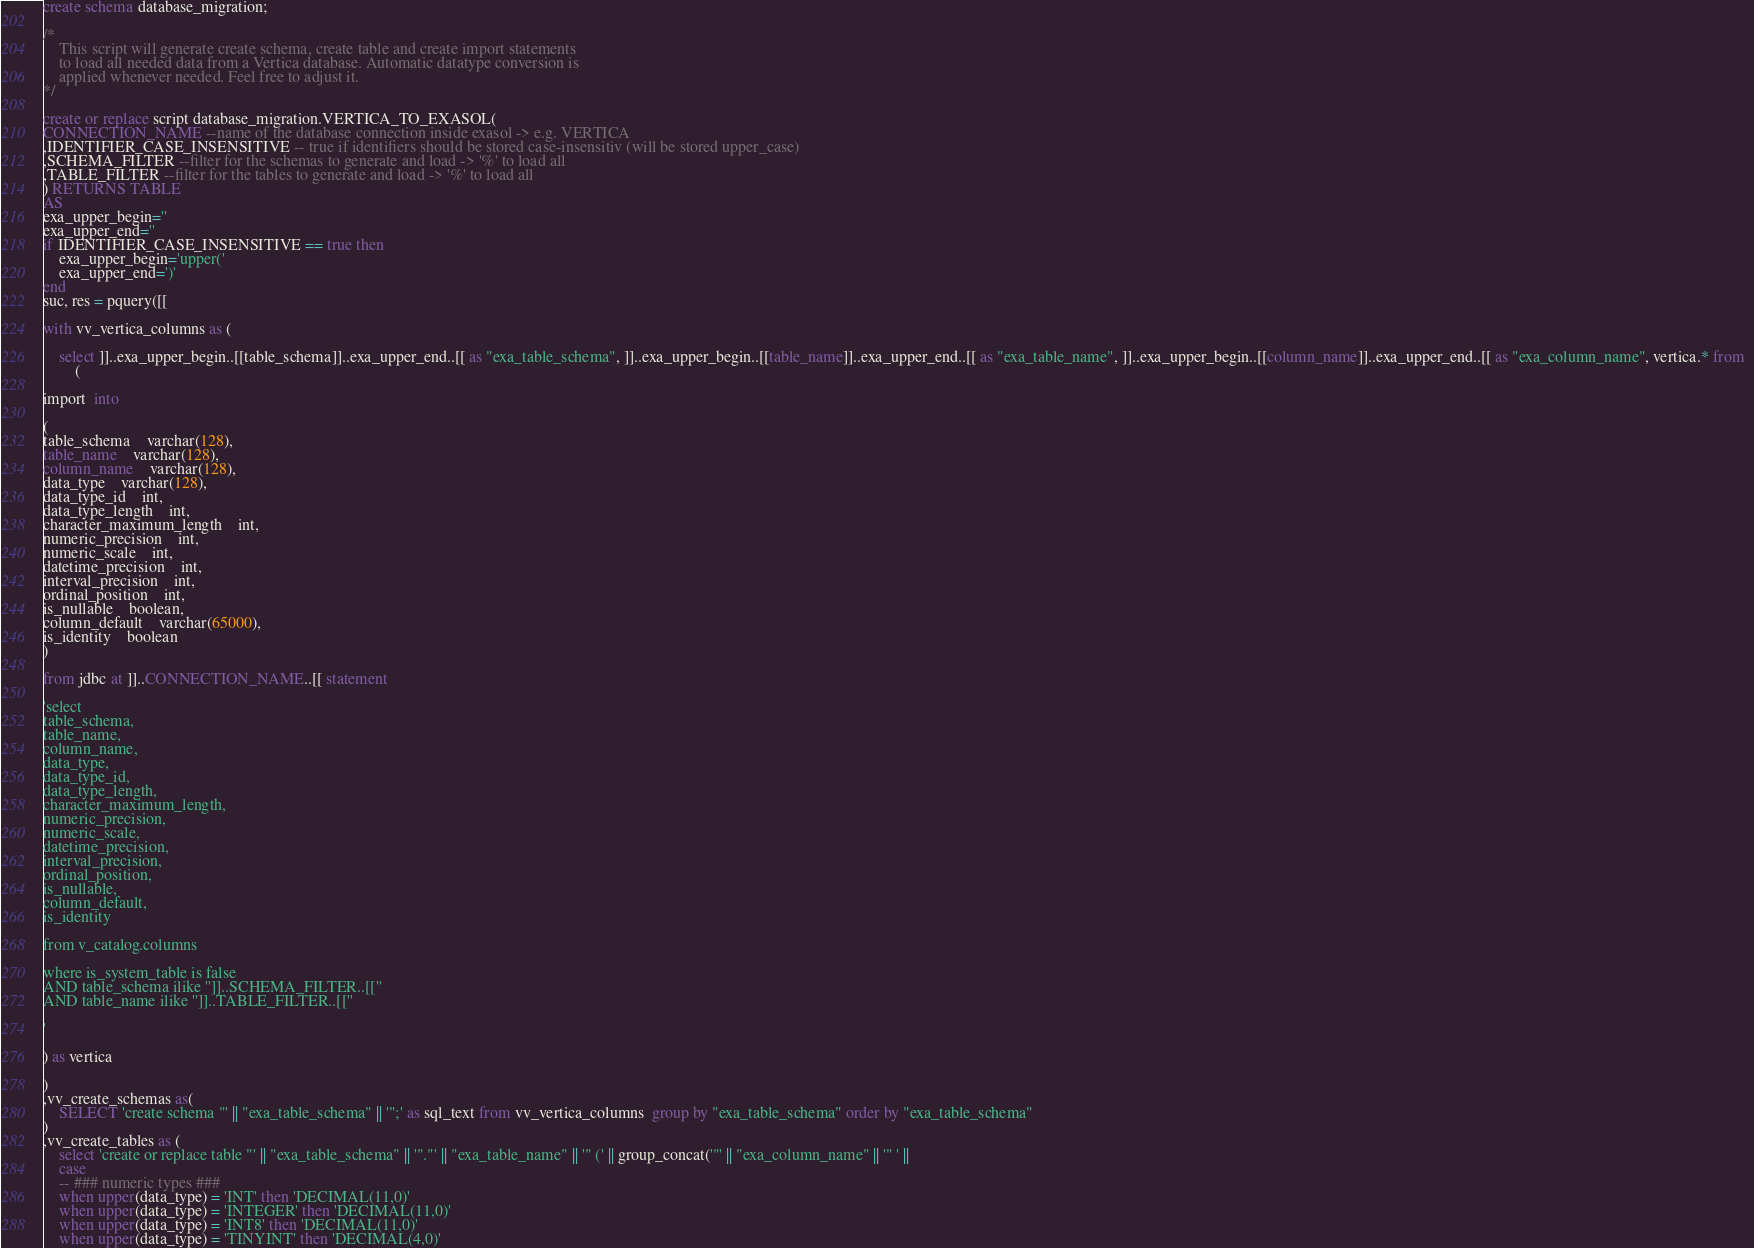<code> <loc_0><loc_0><loc_500><loc_500><_SQL_>create schema database_migration;

/* 
    This script will generate create schema, create table and create import statements 
    to load all needed data from a Vertica database. Automatic datatype conversion is 
    applied whenever needed. Feel free to adjust it. 
*/

create or replace script database_migration.VERTICA_TO_EXASOL(
CONNECTION_NAME --name of the database connection inside exasol -> e.g. VERTICA
,IDENTIFIER_CASE_INSENSITIVE -- true if identifiers should be stored case-insensitiv (will be stored upper_case)
,SCHEMA_FILTER --filter for the schemas to generate and load -> '%' to load all
,TABLE_FILTER --filter for the tables to generate and load -> '%' to load all
) RETURNS TABLE
AS
exa_upper_begin=''
exa_upper_end=''
if IDENTIFIER_CASE_INSENSITIVE == true then
	exa_upper_begin='upper('
	exa_upper_end=')'
end
suc, res = pquery([[

with vv_vertica_columns as (

	select ]]..exa_upper_begin..[[table_schema]]..exa_upper_end..[[ as "exa_table_schema", ]]..exa_upper_begin..[[table_name]]..exa_upper_end..[[ as "exa_table_name", ]]..exa_upper_begin..[[column_name]]..exa_upper_end..[[ as "exa_column_name", vertica.* from  
		(

import  into 

(
table_schema	varchar(128),
table_name	varchar(128),
column_name	varchar(128),
data_type	varchar(128),
data_type_id	int,
data_type_length	int,
character_maximum_length	int,
numeric_precision	int,
numeric_scale	int,
datetime_precision	int,
interval_precision	int,
ordinal_position	int,
is_nullable	boolean,
column_default	varchar(65000),
is_identity	boolean
)

from jdbc at ]]..CONNECTION_NAME..[[ statement 

'select 
table_schema, 
table_name, 
column_name, 
data_type, 
data_type_id, 
data_type_length, 
character_maximum_length, 
numeric_precision, 
numeric_scale, 
datetime_precision, 
interval_precision, 
ordinal_position, 
is_nullable, 
column_default, 
is_identity

from v_catalog.columns

where is_system_table is false
AND table_schema ilike '']]..SCHEMA_FILTER..[[''
AND table_name ilike '']]..TABLE_FILTER..[[''

'

) as vertica 

)
,vv_create_schemas as(
	SELECT 'create schema "' || "exa_table_schema" || '";' as sql_text from vv_vertica_columns  group by "exa_table_schema" order by "exa_table_schema"
)
,vv_create_tables as (
	select 'create or replace table "' || "exa_table_schema" || '"."' || "exa_table_name" || '" (' || group_concat('"' || "exa_column_name" || '" ' ||
	case 
    -- ### numeric types ###
    when upper(data_type) = 'INT' then 'DECIMAL(11,0)'
    when upper(data_type) = 'INTEGER' then 'DECIMAL(11,0)'
	when upper(data_type) = 'INT8' then 'DECIMAL(11,0)'
    when upper(data_type) = 'TINYINT' then 'DECIMAL(4,0)'</code> 